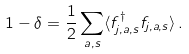<formula> <loc_0><loc_0><loc_500><loc_500>1 - \delta = \frac { 1 } { 2 } \sum _ { a , s } \langle f ^ { \dag } _ { j , a , s } f _ { j , a , s } \rangle \, .</formula> 